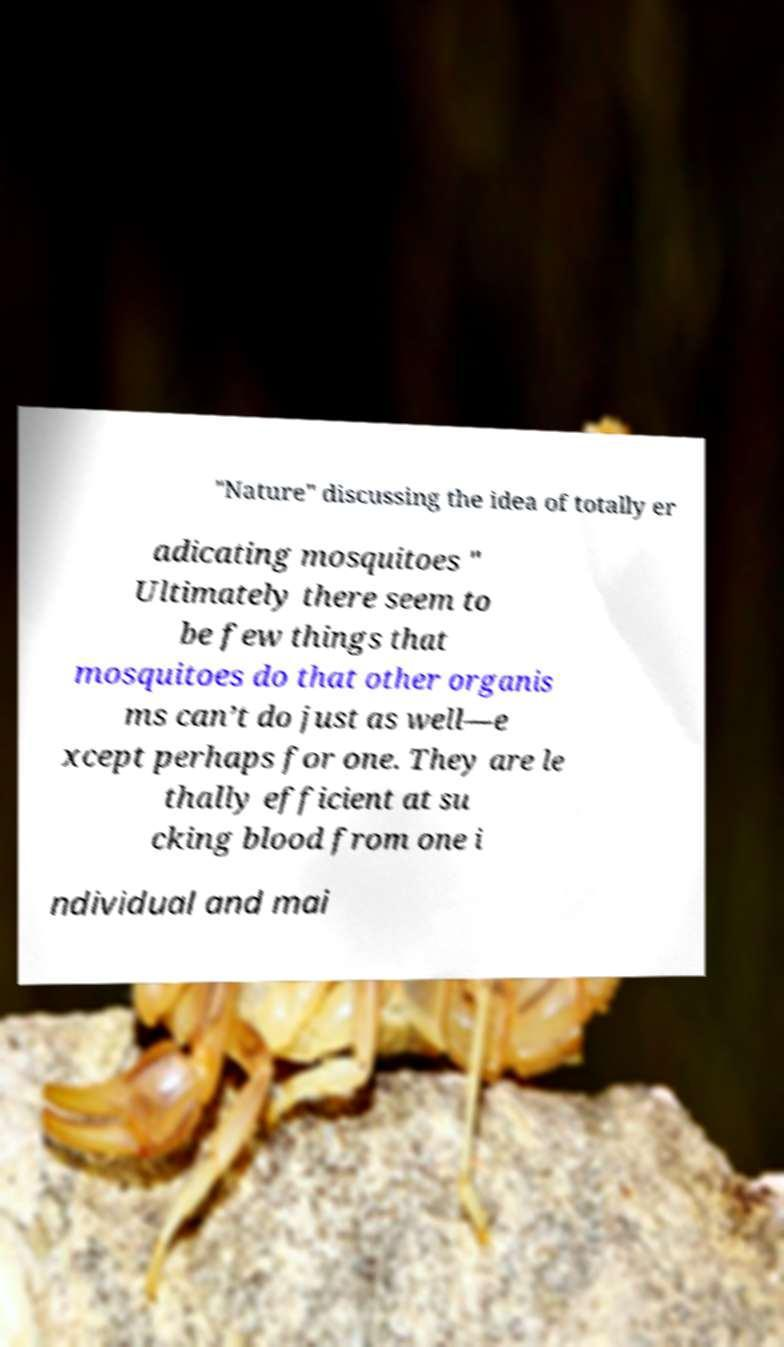What messages or text are displayed in this image? I need them in a readable, typed format. "Nature" discussing the idea of totally er adicating mosquitoes " Ultimately there seem to be few things that mosquitoes do that other organis ms can’t do just as well—e xcept perhaps for one. They are le thally efficient at su cking blood from one i ndividual and mai 